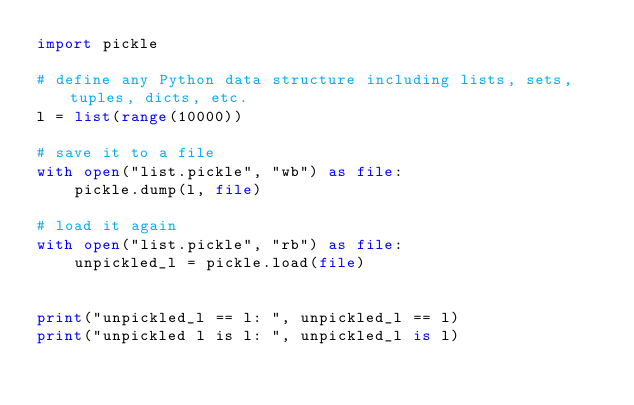<code> <loc_0><loc_0><loc_500><loc_500><_Python_>import pickle

# define any Python data structure including lists, sets, tuples, dicts, etc.
l = list(range(10000))

# save it to a file
with open("list.pickle", "wb") as file:
    pickle.dump(l, file)

# load it again
with open("list.pickle", "rb") as file:
    unpickled_l = pickle.load(file)


print("unpickled_l == l: ", unpickled_l == l)
print("unpickled l is l: ", unpickled_l is l)</code> 